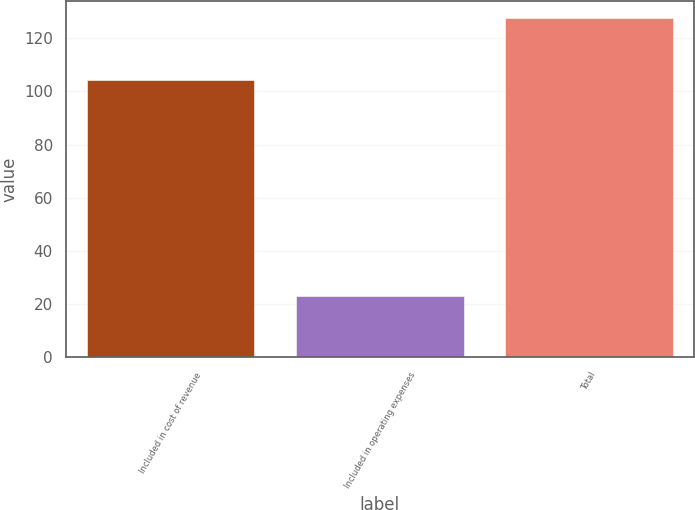<chart> <loc_0><loc_0><loc_500><loc_500><bar_chart><fcel>Included in cost of revenue<fcel>Included in operating expenses<fcel>Total<nl><fcel>104.3<fcel>23.2<fcel>127.5<nl></chart> 